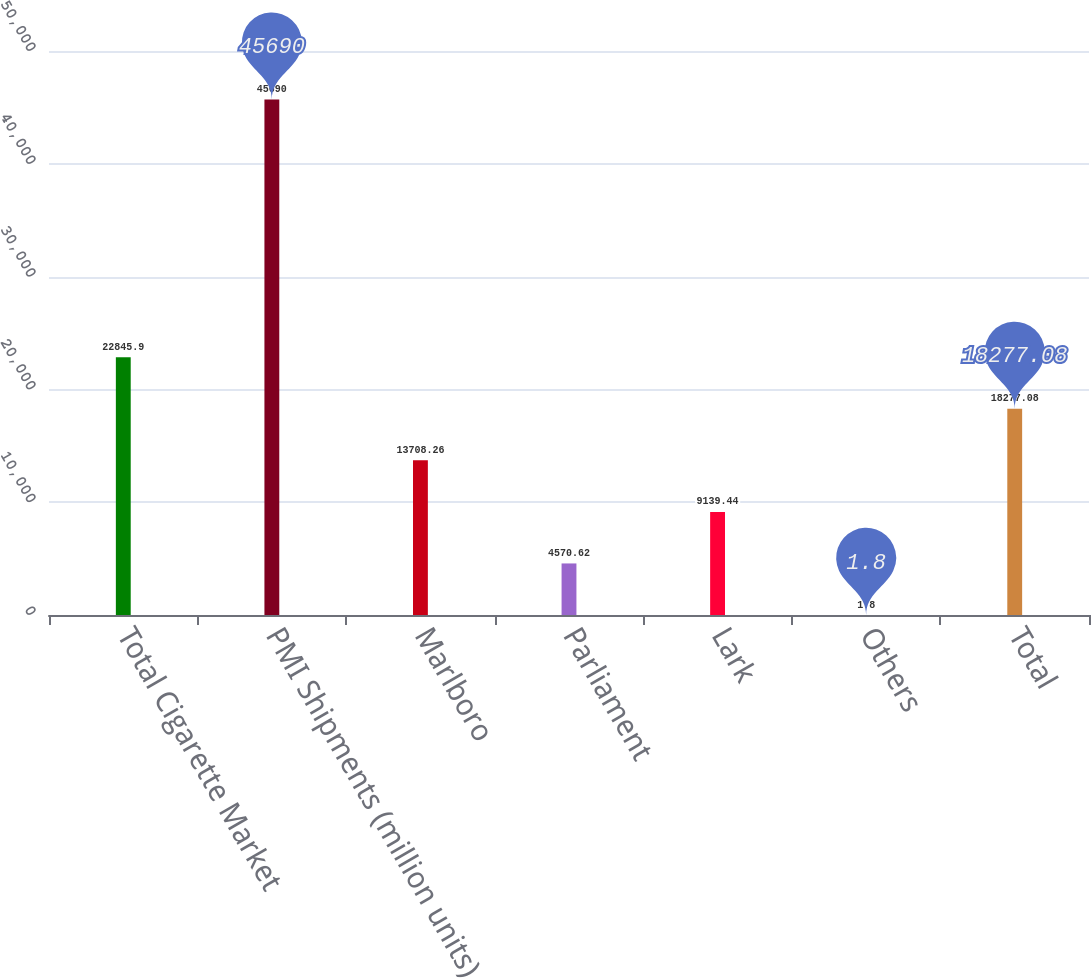Convert chart to OTSL. <chart><loc_0><loc_0><loc_500><loc_500><bar_chart><fcel>Total Cigarette Market<fcel>PMI Shipments (million units)<fcel>Marlboro<fcel>Parliament<fcel>Lark<fcel>Others<fcel>Total<nl><fcel>22845.9<fcel>45690<fcel>13708.3<fcel>4570.62<fcel>9139.44<fcel>1.8<fcel>18277.1<nl></chart> 